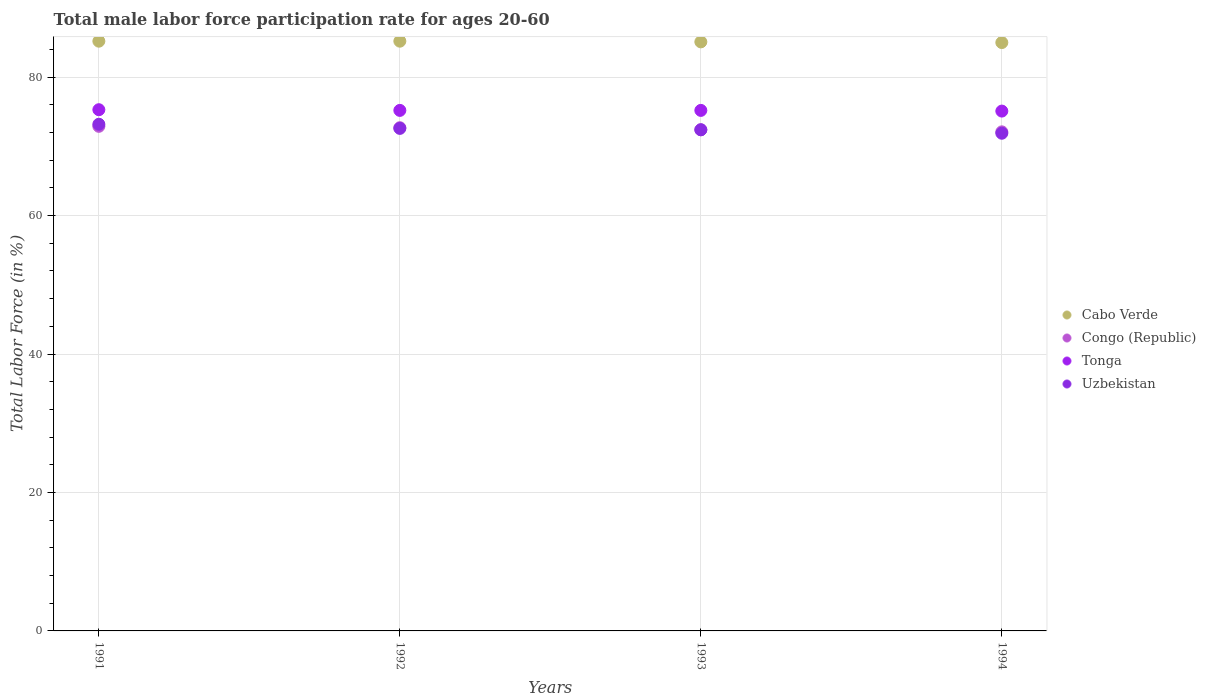Is the number of dotlines equal to the number of legend labels?
Make the answer very short. Yes. What is the male labor force participation rate in Uzbekistan in 1991?
Provide a short and direct response. 73.2. Across all years, what is the maximum male labor force participation rate in Tonga?
Provide a short and direct response. 75.3. Across all years, what is the minimum male labor force participation rate in Tonga?
Your answer should be very brief. 75.1. In which year was the male labor force participation rate in Tonga minimum?
Give a very brief answer. 1994. What is the total male labor force participation rate in Tonga in the graph?
Offer a terse response. 300.8. What is the difference between the male labor force participation rate in Congo (Republic) in 1992 and that in 1994?
Your answer should be compact. 0.6. What is the difference between the male labor force participation rate in Tonga in 1993 and the male labor force participation rate in Cabo Verde in 1994?
Provide a short and direct response. -9.8. What is the average male labor force participation rate in Uzbekistan per year?
Make the answer very short. 72.52. In the year 1994, what is the difference between the male labor force participation rate in Congo (Republic) and male labor force participation rate in Cabo Verde?
Your answer should be very brief. -12.9. In how many years, is the male labor force participation rate in Tonga greater than 44 %?
Offer a terse response. 4. What is the ratio of the male labor force participation rate in Uzbekistan in 1992 to that in 1994?
Keep it short and to the point. 1.01. Is the male labor force participation rate in Congo (Republic) in 1992 less than that in 1993?
Keep it short and to the point. No. Is the difference between the male labor force participation rate in Congo (Republic) in 1992 and 1994 greater than the difference between the male labor force participation rate in Cabo Verde in 1992 and 1994?
Offer a terse response. Yes. What is the difference between the highest and the second highest male labor force participation rate in Uzbekistan?
Make the answer very short. 0.6. What is the difference between the highest and the lowest male labor force participation rate in Tonga?
Provide a succinct answer. 0.2. Is the sum of the male labor force participation rate in Cabo Verde in 1991 and 1992 greater than the maximum male labor force participation rate in Uzbekistan across all years?
Give a very brief answer. Yes. Is it the case that in every year, the sum of the male labor force participation rate in Cabo Verde and male labor force participation rate in Congo (Republic)  is greater than the male labor force participation rate in Uzbekistan?
Your answer should be compact. Yes. Does the male labor force participation rate in Tonga monotonically increase over the years?
Provide a succinct answer. No. Is the male labor force participation rate in Cabo Verde strictly greater than the male labor force participation rate in Uzbekistan over the years?
Your answer should be compact. Yes. Is the male labor force participation rate in Cabo Verde strictly less than the male labor force participation rate in Congo (Republic) over the years?
Your answer should be very brief. No. How many years are there in the graph?
Provide a short and direct response. 4. What is the difference between two consecutive major ticks on the Y-axis?
Provide a short and direct response. 20. How many legend labels are there?
Provide a short and direct response. 4. How are the legend labels stacked?
Ensure brevity in your answer.  Vertical. What is the title of the graph?
Give a very brief answer. Total male labor force participation rate for ages 20-60. Does "Bangladesh" appear as one of the legend labels in the graph?
Your answer should be very brief. No. What is the label or title of the Y-axis?
Ensure brevity in your answer.  Total Labor Force (in %). What is the Total Labor Force (in %) of Cabo Verde in 1991?
Offer a terse response. 85.2. What is the Total Labor Force (in %) of Congo (Republic) in 1991?
Provide a short and direct response. 72.9. What is the Total Labor Force (in %) of Tonga in 1991?
Offer a very short reply. 75.3. What is the Total Labor Force (in %) in Uzbekistan in 1991?
Give a very brief answer. 73.2. What is the Total Labor Force (in %) of Cabo Verde in 1992?
Your response must be concise. 85.2. What is the Total Labor Force (in %) of Congo (Republic) in 1992?
Provide a short and direct response. 72.7. What is the Total Labor Force (in %) in Tonga in 1992?
Offer a very short reply. 75.2. What is the Total Labor Force (in %) of Uzbekistan in 1992?
Ensure brevity in your answer.  72.6. What is the Total Labor Force (in %) in Cabo Verde in 1993?
Offer a terse response. 85.1. What is the Total Labor Force (in %) in Congo (Republic) in 1993?
Your answer should be very brief. 72.4. What is the Total Labor Force (in %) of Tonga in 1993?
Offer a very short reply. 75.2. What is the Total Labor Force (in %) in Uzbekistan in 1993?
Provide a succinct answer. 72.4. What is the Total Labor Force (in %) of Cabo Verde in 1994?
Your answer should be very brief. 85. What is the Total Labor Force (in %) of Congo (Republic) in 1994?
Your answer should be compact. 72.1. What is the Total Labor Force (in %) of Tonga in 1994?
Your answer should be very brief. 75.1. What is the Total Labor Force (in %) in Uzbekistan in 1994?
Offer a very short reply. 71.9. Across all years, what is the maximum Total Labor Force (in %) of Cabo Verde?
Offer a terse response. 85.2. Across all years, what is the maximum Total Labor Force (in %) of Congo (Republic)?
Provide a succinct answer. 72.9. Across all years, what is the maximum Total Labor Force (in %) in Tonga?
Offer a terse response. 75.3. Across all years, what is the maximum Total Labor Force (in %) of Uzbekistan?
Your answer should be very brief. 73.2. Across all years, what is the minimum Total Labor Force (in %) in Congo (Republic)?
Your answer should be very brief. 72.1. Across all years, what is the minimum Total Labor Force (in %) in Tonga?
Provide a short and direct response. 75.1. Across all years, what is the minimum Total Labor Force (in %) of Uzbekistan?
Your response must be concise. 71.9. What is the total Total Labor Force (in %) in Cabo Verde in the graph?
Your response must be concise. 340.5. What is the total Total Labor Force (in %) of Congo (Republic) in the graph?
Your answer should be compact. 290.1. What is the total Total Labor Force (in %) of Tonga in the graph?
Provide a succinct answer. 300.8. What is the total Total Labor Force (in %) of Uzbekistan in the graph?
Provide a succinct answer. 290.1. What is the difference between the Total Labor Force (in %) of Cabo Verde in 1991 and that in 1992?
Give a very brief answer. 0. What is the difference between the Total Labor Force (in %) of Congo (Republic) in 1991 and that in 1992?
Your answer should be very brief. 0.2. What is the difference between the Total Labor Force (in %) in Tonga in 1991 and that in 1992?
Ensure brevity in your answer.  0.1. What is the difference between the Total Labor Force (in %) in Tonga in 1991 and that in 1993?
Provide a succinct answer. 0.1. What is the difference between the Total Labor Force (in %) in Uzbekistan in 1991 and that in 1993?
Your answer should be compact. 0.8. What is the difference between the Total Labor Force (in %) of Congo (Republic) in 1991 and that in 1994?
Provide a short and direct response. 0.8. What is the difference between the Total Labor Force (in %) of Tonga in 1991 and that in 1994?
Keep it short and to the point. 0.2. What is the difference between the Total Labor Force (in %) of Uzbekistan in 1991 and that in 1994?
Make the answer very short. 1.3. What is the difference between the Total Labor Force (in %) of Cabo Verde in 1992 and that in 1993?
Keep it short and to the point. 0.1. What is the difference between the Total Labor Force (in %) of Congo (Republic) in 1992 and that in 1993?
Ensure brevity in your answer.  0.3. What is the difference between the Total Labor Force (in %) of Uzbekistan in 1992 and that in 1993?
Ensure brevity in your answer.  0.2. What is the difference between the Total Labor Force (in %) of Cabo Verde in 1992 and that in 1994?
Make the answer very short. 0.2. What is the difference between the Total Labor Force (in %) in Congo (Republic) in 1992 and that in 1994?
Offer a very short reply. 0.6. What is the difference between the Total Labor Force (in %) of Tonga in 1992 and that in 1994?
Your response must be concise. 0.1. What is the difference between the Total Labor Force (in %) in Cabo Verde in 1993 and that in 1994?
Offer a terse response. 0.1. What is the difference between the Total Labor Force (in %) in Uzbekistan in 1993 and that in 1994?
Provide a short and direct response. 0.5. What is the difference between the Total Labor Force (in %) in Cabo Verde in 1991 and the Total Labor Force (in %) in Congo (Republic) in 1992?
Your response must be concise. 12.5. What is the difference between the Total Labor Force (in %) in Cabo Verde in 1991 and the Total Labor Force (in %) in Tonga in 1992?
Your response must be concise. 10. What is the difference between the Total Labor Force (in %) in Cabo Verde in 1991 and the Total Labor Force (in %) in Uzbekistan in 1992?
Your response must be concise. 12.6. What is the difference between the Total Labor Force (in %) of Congo (Republic) in 1991 and the Total Labor Force (in %) of Tonga in 1992?
Your answer should be very brief. -2.3. What is the difference between the Total Labor Force (in %) in Tonga in 1991 and the Total Labor Force (in %) in Uzbekistan in 1992?
Provide a short and direct response. 2.7. What is the difference between the Total Labor Force (in %) of Cabo Verde in 1991 and the Total Labor Force (in %) of Congo (Republic) in 1993?
Your response must be concise. 12.8. What is the difference between the Total Labor Force (in %) in Cabo Verde in 1991 and the Total Labor Force (in %) in Tonga in 1993?
Ensure brevity in your answer.  10. What is the difference between the Total Labor Force (in %) of Cabo Verde in 1991 and the Total Labor Force (in %) of Congo (Republic) in 1994?
Give a very brief answer. 13.1. What is the difference between the Total Labor Force (in %) in Congo (Republic) in 1991 and the Total Labor Force (in %) in Tonga in 1994?
Give a very brief answer. -2.2. What is the difference between the Total Labor Force (in %) in Congo (Republic) in 1991 and the Total Labor Force (in %) in Uzbekistan in 1994?
Your response must be concise. 1. What is the difference between the Total Labor Force (in %) of Cabo Verde in 1992 and the Total Labor Force (in %) of Congo (Republic) in 1993?
Provide a short and direct response. 12.8. What is the difference between the Total Labor Force (in %) in Cabo Verde in 1992 and the Total Labor Force (in %) in Tonga in 1993?
Give a very brief answer. 10. What is the difference between the Total Labor Force (in %) in Cabo Verde in 1992 and the Total Labor Force (in %) in Uzbekistan in 1993?
Ensure brevity in your answer.  12.8. What is the difference between the Total Labor Force (in %) of Congo (Republic) in 1992 and the Total Labor Force (in %) of Uzbekistan in 1993?
Offer a terse response. 0.3. What is the difference between the Total Labor Force (in %) in Cabo Verde in 1992 and the Total Labor Force (in %) in Congo (Republic) in 1994?
Provide a succinct answer. 13.1. What is the difference between the Total Labor Force (in %) in Cabo Verde in 1992 and the Total Labor Force (in %) in Tonga in 1994?
Provide a succinct answer. 10.1. What is the difference between the Total Labor Force (in %) in Cabo Verde in 1992 and the Total Labor Force (in %) in Uzbekistan in 1994?
Keep it short and to the point. 13.3. What is the difference between the Total Labor Force (in %) of Congo (Republic) in 1992 and the Total Labor Force (in %) of Tonga in 1994?
Offer a terse response. -2.4. What is the difference between the Total Labor Force (in %) of Tonga in 1992 and the Total Labor Force (in %) of Uzbekistan in 1994?
Your answer should be very brief. 3.3. What is the difference between the Total Labor Force (in %) in Cabo Verde in 1993 and the Total Labor Force (in %) in Congo (Republic) in 1994?
Provide a short and direct response. 13. What is the difference between the Total Labor Force (in %) of Cabo Verde in 1993 and the Total Labor Force (in %) of Tonga in 1994?
Your answer should be very brief. 10. What is the difference between the Total Labor Force (in %) in Congo (Republic) in 1993 and the Total Labor Force (in %) in Tonga in 1994?
Ensure brevity in your answer.  -2.7. What is the difference between the Total Labor Force (in %) of Congo (Republic) in 1993 and the Total Labor Force (in %) of Uzbekistan in 1994?
Your answer should be very brief. 0.5. What is the average Total Labor Force (in %) of Cabo Verde per year?
Offer a terse response. 85.12. What is the average Total Labor Force (in %) in Congo (Republic) per year?
Keep it short and to the point. 72.53. What is the average Total Labor Force (in %) in Tonga per year?
Your answer should be compact. 75.2. What is the average Total Labor Force (in %) of Uzbekistan per year?
Offer a terse response. 72.53. In the year 1991, what is the difference between the Total Labor Force (in %) in Cabo Verde and Total Labor Force (in %) in Uzbekistan?
Offer a terse response. 12. In the year 1991, what is the difference between the Total Labor Force (in %) in Congo (Republic) and Total Labor Force (in %) in Tonga?
Give a very brief answer. -2.4. In the year 1992, what is the difference between the Total Labor Force (in %) in Congo (Republic) and Total Labor Force (in %) in Uzbekistan?
Give a very brief answer. 0.1. In the year 1993, what is the difference between the Total Labor Force (in %) of Cabo Verde and Total Labor Force (in %) of Tonga?
Provide a short and direct response. 9.9. In the year 1993, what is the difference between the Total Labor Force (in %) in Congo (Republic) and Total Labor Force (in %) in Tonga?
Give a very brief answer. -2.8. In the year 1993, what is the difference between the Total Labor Force (in %) of Congo (Republic) and Total Labor Force (in %) of Uzbekistan?
Offer a terse response. 0. In the year 1994, what is the difference between the Total Labor Force (in %) of Cabo Verde and Total Labor Force (in %) of Uzbekistan?
Give a very brief answer. 13.1. In the year 1994, what is the difference between the Total Labor Force (in %) in Congo (Republic) and Total Labor Force (in %) in Uzbekistan?
Ensure brevity in your answer.  0.2. In the year 1994, what is the difference between the Total Labor Force (in %) in Tonga and Total Labor Force (in %) in Uzbekistan?
Provide a succinct answer. 3.2. What is the ratio of the Total Labor Force (in %) in Uzbekistan in 1991 to that in 1992?
Make the answer very short. 1.01. What is the ratio of the Total Labor Force (in %) in Congo (Republic) in 1991 to that in 1994?
Provide a succinct answer. 1.01. What is the ratio of the Total Labor Force (in %) of Uzbekistan in 1991 to that in 1994?
Your answer should be very brief. 1.02. What is the ratio of the Total Labor Force (in %) in Congo (Republic) in 1992 to that in 1993?
Your response must be concise. 1. What is the ratio of the Total Labor Force (in %) of Tonga in 1992 to that in 1993?
Provide a succinct answer. 1. What is the ratio of the Total Labor Force (in %) of Uzbekistan in 1992 to that in 1993?
Your answer should be very brief. 1. What is the ratio of the Total Labor Force (in %) in Cabo Verde in 1992 to that in 1994?
Your answer should be very brief. 1. What is the ratio of the Total Labor Force (in %) in Congo (Republic) in 1992 to that in 1994?
Keep it short and to the point. 1.01. What is the ratio of the Total Labor Force (in %) in Tonga in 1992 to that in 1994?
Make the answer very short. 1. What is the ratio of the Total Labor Force (in %) in Uzbekistan in 1992 to that in 1994?
Your answer should be very brief. 1.01. What is the ratio of the Total Labor Force (in %) in Tonga in 1993 to that in 1994?
Provide a succinct answer. 1. What is the difference between the highest and the second highest Total Labor Force (in %) of Cabo Verde?
Keep it short and to the point. 0. What is the difference between the highest and the second highest Total Labor Force (in %) of Uzbekistan?
Provide a succinct answer. 0.6. What is the difference between the highest and the lowest Total Labor Force (in %) in Tonga?
Your answer should be compact. 0.2. What is the difference between the highest and the lowest Total Labor Force (in %) in Uzbekistan?
Your answer should be compact. 1.3. 